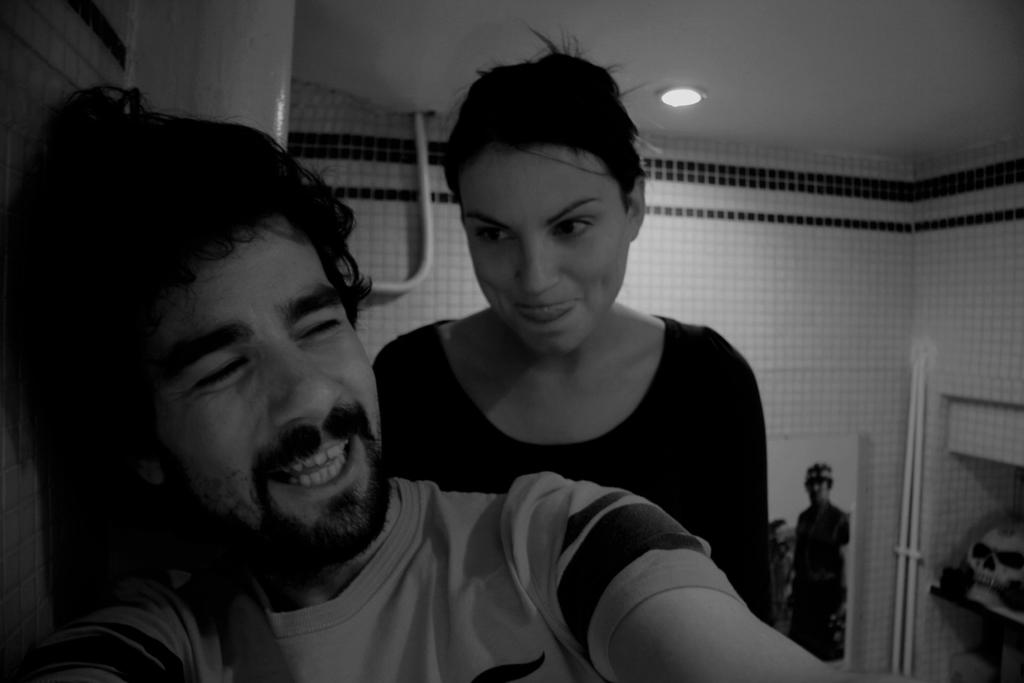How many people are present in the image? There are two persons in the image. What type of structure is visible in the image? There are walls and a roof visible in the image. What might be used for illumination in the image? There is a light visible in the image. What type of tomatoes can be seen growing on the walls in the image? There are no tomatoes present in the image; only walls and a roof are visible. How many boats can be seen sailing in the image? There are no boats present in the image. 